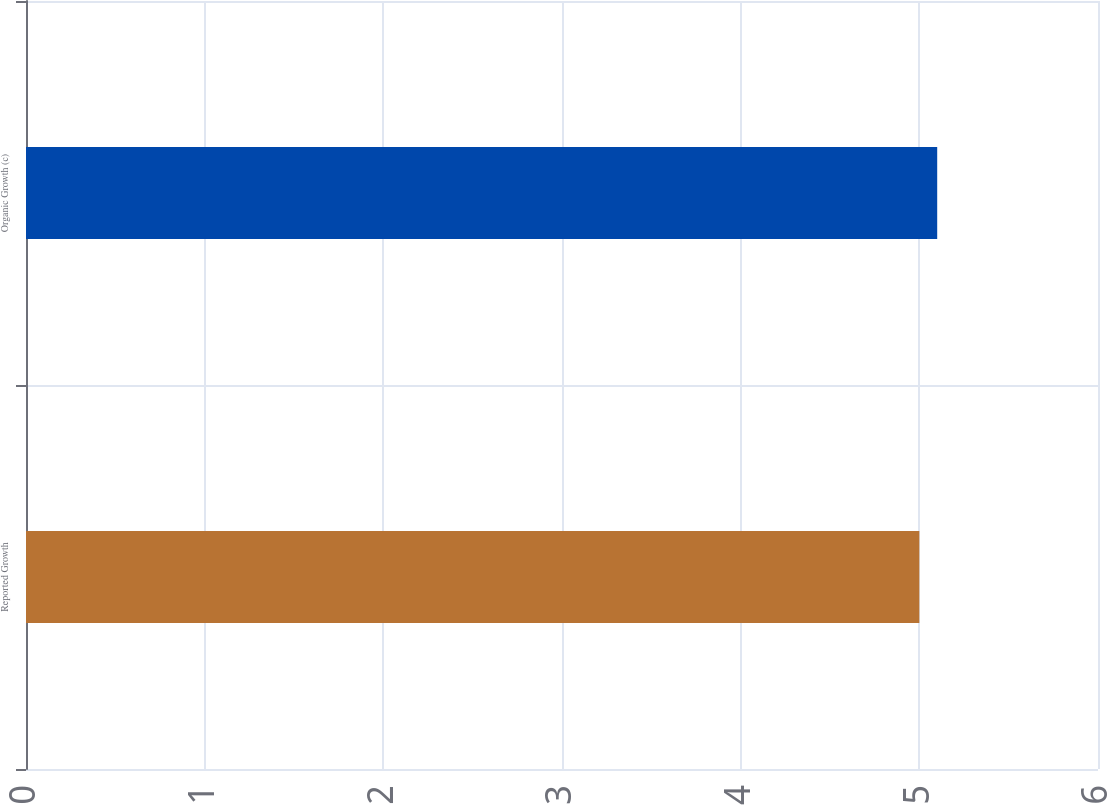Convert chart. <chart><loc_0><loc_0><loc_500><loc_500><bar_chart><fcel>Reported Growth<fcel>Organic Growth (c)<nl><fcel>5<fcel>5.1<nl></chart> 